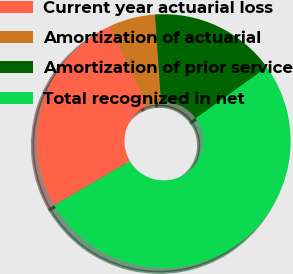Convert chart to OTSL. <chart><loc_0><loc_0><loc_500><loc_500><pie_chart><fcel>Current year actuarial loss<fcel>Amortization of actuarial<fcel>Amortization of prior service<fcel>Total recognized in net<nl><fcel>26.47%<fcel>5.88%<fcel>16.18%<fcel>51.47%<nl></chart> 